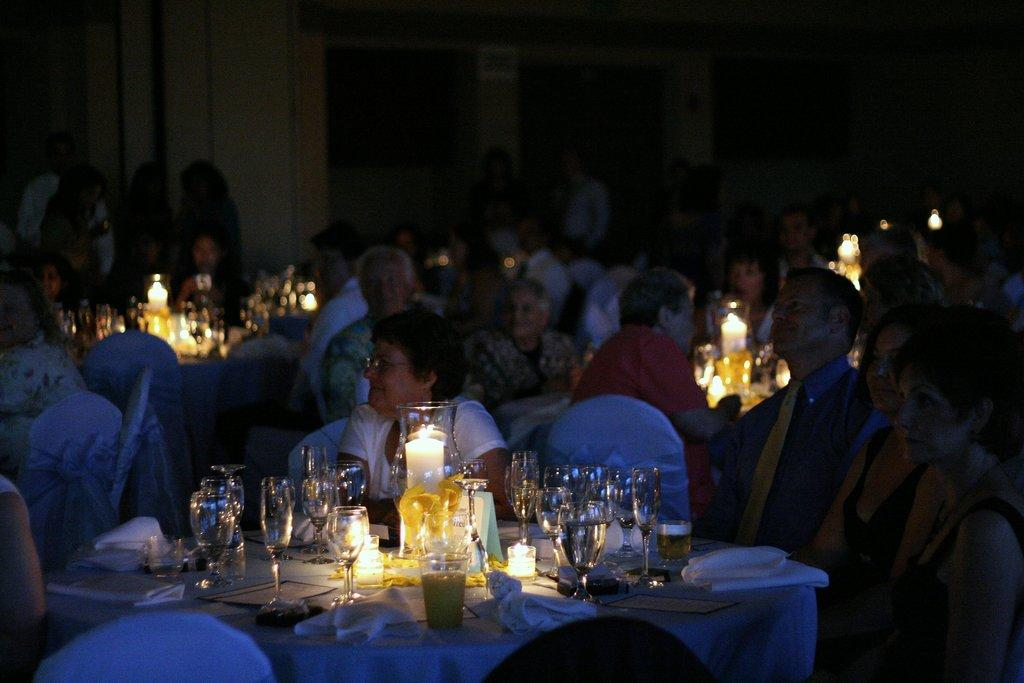What are the people in the image doing? The people in the image are sitting on chairs. What is in front of the chairs? There are tables in front of the chairs. What can be seen on the tables? There are glasses and candles on the tables. Are there any other objects on the tables? Yes, there are other objects on the tables. How does the image capture the attention of the people sitting on chairs? The image does not capture the attention of the people sitting on chairs, as it is a static representation of the scene. 